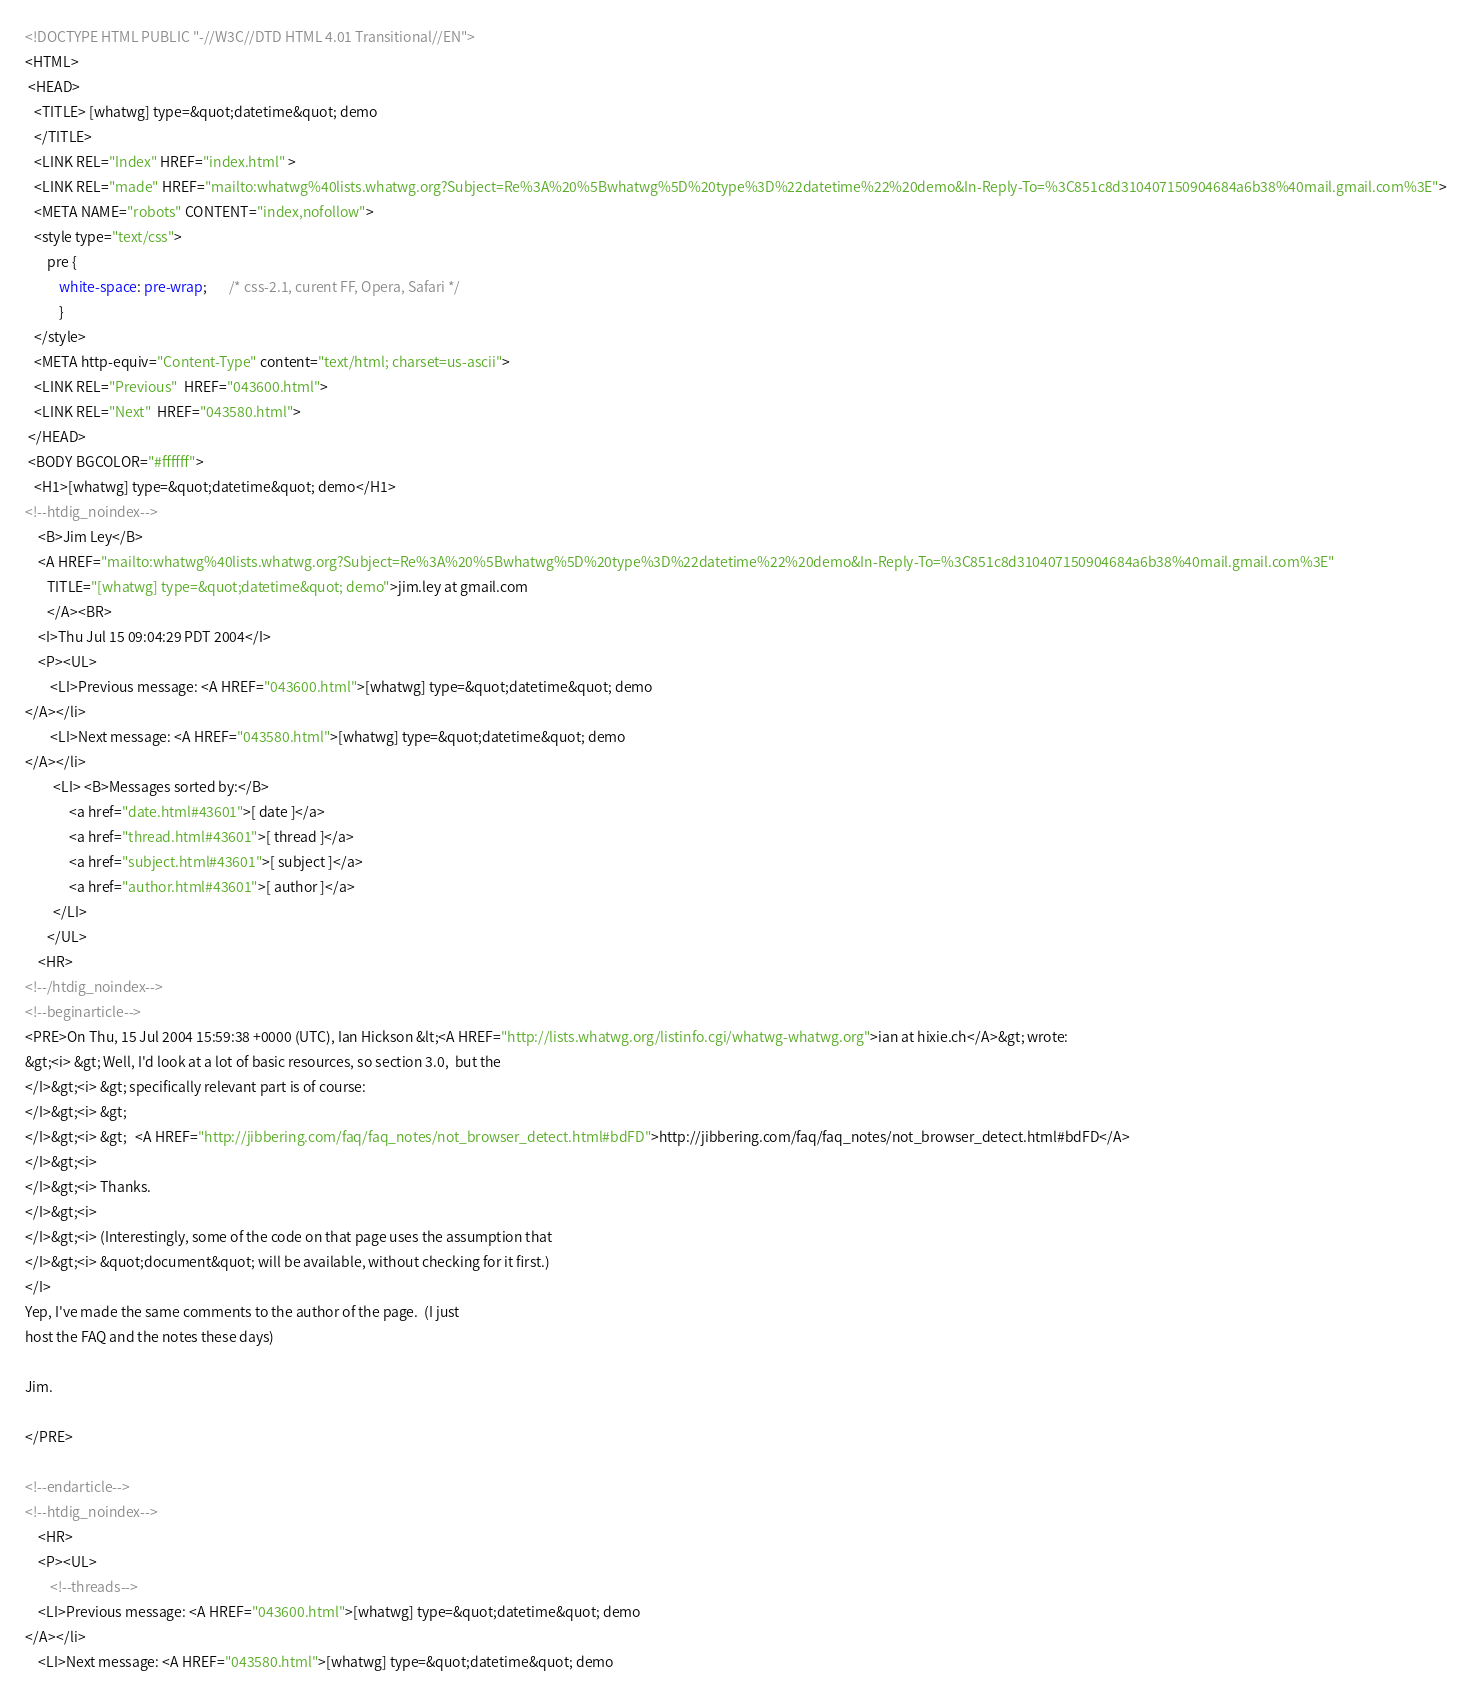Convert code to text. <code><loc_0><loc_0><loc_500><loc_500><_HTML_><!DOCTYPE HTML PUBLIC "-//W3C//DTD HTML 4.01 Transitional//EN">
<HTML>
 <HEAD>
   <TITLE> [whatwg] type=&quot;datetime&quot; demo
   </TITLE>
   <LINK REL="Index" HREF="index.html" >
   <LINK REL="made" HREF="mailto:whatwg%40lists.whatwg.org?Subject=Re%3A%20%5Bwhatwg%5D%20type%3D%22datetime%22%20demo&In-Reply-To=%3C851c8d310407150904684a6b38%40mail.gmail.com%3E">
   <META NAME="robots" CONTENT="index,nofollow">
   <style type="text/css">
       pre {
           white-space: pre-wrap;       /* css-2.1, curent FF, Opera, Safari */
           }
   </style>
   <META http-equiv="Content-Type" content="text/html; charset=us-ascii">
   <LINK REL="Previous"  HREF="043600.html">
   <LINK REL="Next"  HREF="043580.html">
 </HEAD>
 <BODY BGCOLOR="#ffffff">
   <H1>[whatwg] type=&quot;datetime&quot; demo</H1>
<!--htdig_noindex-->
    <B>Jim Ley</B> 
    <A HREF="mailto:whatwg%40lists.whatwg.org?Subject=Re%3A%20%5Bwhatwg%5D%20type%3D%22datetime%22%20demo&In-Reply-To=%3C851c8d310407150904684a6b38%40mail.gmail.com%3E"
       TITLE="[whatwg] type=&quot;datetime&quot; demo">jim.ley at gmail.com
       </A><BR>
    <I>Thu Jul 15 09:04:29 PDT 2004</I>
    <P><UL>
        <LI>Previous message: <A HREF="043600.html">[whatwg] type=&quot;datetime&quot; demo
</A></li>
        <LI>Next message: <A HREF="043580.html">[whatwg] type=&quot;datetime&quot; demo
</A></li>
         <LI> <B>Messages sorted by:</B> 
              <a href="date.html#43601">[ date ]</a>
              <a href="thread.html#43601">[ thread ]</a>
              <a href="subject.html#43601">[ subject ]</a>
              <a href="author.html#43601">[ author ]</a>
         </LI>
       </UL>
    <HR>  
<!--/htdig_noindex-->
<!--beginarticle-->
<PRE>On Thu, 15 Jul 2004 15:59:38 +0000 (UTC), Ian Hickson &lt;<A HREF="http://lists.whatwg.org/listinfo.cgi/whatwg-whatwg.org">ian at hixie.ch</A>&gt; wrote:
&gt;<i> &gt; Well, I'd look at a lot of basic resources, so section 3.0,  but the
</I>&gt;<i> &gt; specifically relevant part is of course:
</I>&gt;<i> &gt;
</I>&gt;<i> &gt;   <A HREF="http://jibbering.com/faq/faq_notes/not_browser_detect.html#bdFD">http://jibbering.com/faq/faq_notes/not_browser_detect.html#bdFD</A>
</I>&gt;<i> 
</I>&gt;<i> Thanks.
</I>&gt;<i> 
</I>&gt;<i> (Interestingly, some of the code on that page uses the assumption that
</I>&gt;<i> &quot;document&quot; will be available, without checking for it first.)
</I>
Yep, I've made the same comments to the author of the page.  (I just
host the FAQ and the notes these days)

Jim.

</PRE>

<!--endarticle-->
<!--htdig_noindex-->
    <HR>
    <P><UL>
        <!--threads-->
	<LI>Previous message: <A HREF="043600.html">[whatwg] type=&quot;datetime&quot; demo
</A></li>
	<LI>Next message: <A HREF="043580.html">[whatwg] type=&quot;datetime&quot; demo</code> 